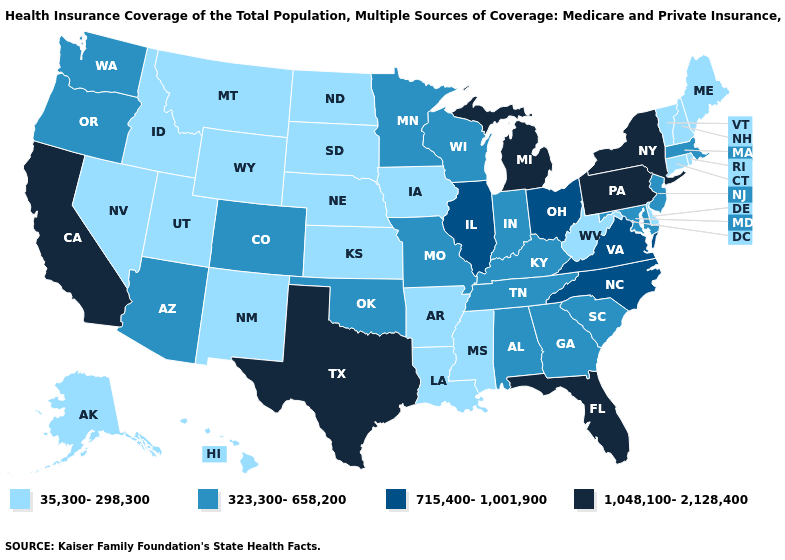Name the states that have a value in the range 1,048,100-2,128,400?
Quick response, please. California, Florida, Michigan, New York, Pennsylvania, Texas. Does New York have the same value as Virginia?
Write a very short answer. No. Does Alabama have the same value as Wyoming?
Quick response, please. No. What is the highest value in states that border Michigan?
Give a very brief answer. 715,400-1,001,900. Does California have the highest value in the USA?
Be succinct. Yes. What is the value of Maine?
Keep it brief. 35,300-298,300. How many symbols are there in the legend?
Write a very short answer. 4. Which states have the highest value in the USA?
Answer briefly. California, Florida, Michigan, New York, Pennsylvania, Texas. Does the map have missing data?
Quick response, please. No. What is the highest value in states that border New Jersey?
Keep it brief. 1,048,100-2,128,400. Does North Carolina have the highest value in the South?
Answer briefly. No. Among the states that border New York , which have the lowest value?
Answer briefly. Connecticut, Vermont. Among the states that border Oregon , does Nevada have the lowest value?
Be succinct. Yes. Among the states that border Wisconsin , which have the highest value?
Concise answer only. Michigan. What is the lowest value in the USA?
Quick response, please. 35,300-298,300. 